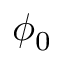<formula> <loc_0><loc_0><loc_500><loc_500>\phi _ { 0 }</formula> 